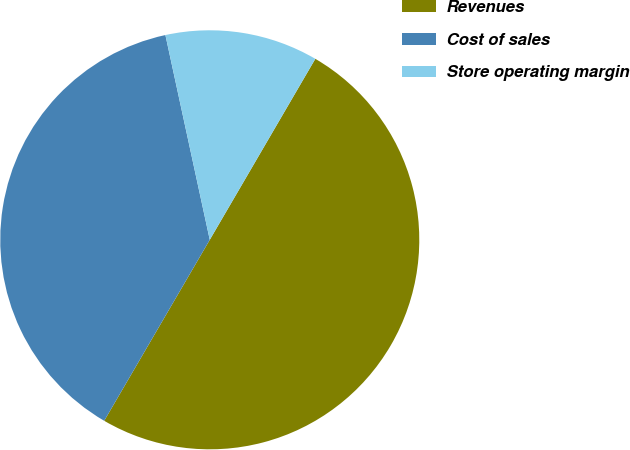<chart> <loc_0><loc_0><loc_500><loc_500><pie_chart><fcel>Revenues<fcel>Cost of sales<fcel>Store operating margin<nl><fcel>50.0%<fcel>38.2%<fcel>11.8%<nl></chart> 